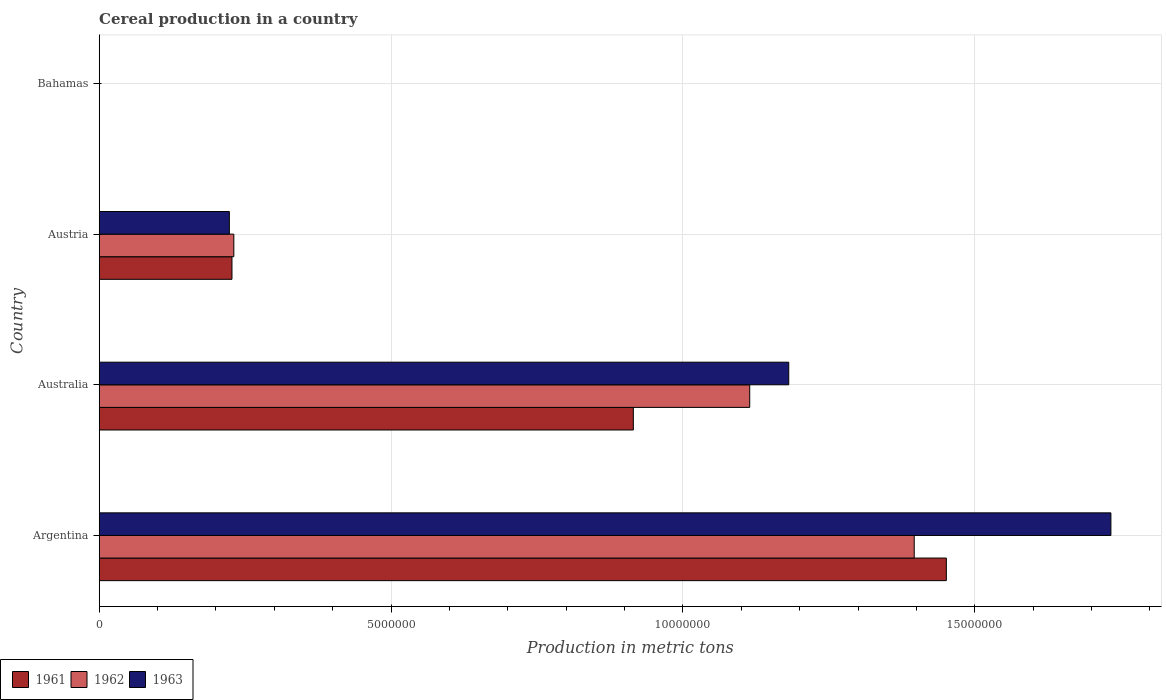How many groups of bars are there?
Offer a very short reply. 4. How many bars are there on the 3rd tick from the top?
Offer a terse response. 3. How many bars are there on the 2nd tick from the bottom?
Ensure brevity in your answer.  3. In how many cases, is the number of bars for a given country not equal to the number of legend labels?
Your response must be concise. 0. What is the total cereal production in 1962 in Bahamas?
Ensure brevity in your answer.  150. Across all countries, what is the maximum total cereal production in 1961?
Provide a short and direct response. 1.45e+07. In which country was the total cereal production in 1963 maximum?
Provide a short and direct response. Argentina. In which country was the total cereal production in 1961 minimum?
Provide a short and direct response. Bahamas. What is the total total cereal production in 1962 in the graph?
Your response must be concise. 2.74e+07. What is the difference between the total cereal production in 1963 in Argentina and that in Bahamas?
Provide a short and direct response. 1.73e+07. What is the difference between the total cereal production in 1962 in Bahamas and the total cereal production in 1961 in Australia?
Provide a succinct answer. -9.15e+06. What is the average total cereal production in 1963 per country?
Offer a very short reply. 7.84e+06. What is the difference between the total cereal production in 1963 and total cereal production in 1961 in Bahamas?
Provide a succinct answer. 100. In how many countries, is the total cereal production in 1962 greater than 7000000 metric tons?
Provide a short and direct response. 2. What is the ratio of the total cereal production in 1961 in Argentina to that in Australia?
Offer a very short reply. 1.59. What is the difference between the highest and the second highest total cereal production in 1962?
Provide a succinct answer. 2.82e+06. What is the difference between the highest and the lowest total cereal production in 1961?
Provide a short and direct response. 1.45e+07. In how many countries, is the total cereal production in 1961 greater than the average total cereal production in 1961 taken over all countries?
Your answer should be compact. 2. Is it the case that in every country, the sum of the total cereal production in 1963 and total cereal production in 1961 is greater than the total cereal production in 1962?
Keep it short and to the point. Yes. How many countries are there in the graph?
Your answer should be compact. 4. Are the values on the major ticks of X-axis written in scientific E-notation?
Give a very brief answer. No. Does the graph contain any zero values?
Provide a short and direct response. No. How many legend labels are there?
Your answer should be compact. 3. What is the title of the graph?
Offer a very short reply. Cereal production in a country. Does "1994" appear as one of the legend labels in the graph?
Ensure brevity in your answer.  No. What is the label or title of the X-axis?
Make the answer very short. Production in metric tons. What is the label or title of the Y-axis?
Your answer should be compact. Country. What is the Production in metric tons in 1961 in Argentina?
Your answer should be very brief. 1.45e+07. What is the Production in metric tons in 1962 in Argentina?
Your answer should be compact. 1.40e+07. What is the Production in metric tons of 1963 in Argentina?
Give a very brief answer. 1.73e+07. What is the Production in metric tons in 1961 in Australia?
Provide a succinct answer. 9.15e+06. What is the Production in metric tons of 1962 in Australia?
Your answer should be compact. 1.11e+07. What is the Production in metric tons of 1963 in Australia?
Offer a very short reply. 1.18e+07. What is the Production in metric tons of 1961 in Austria?
Make the answer very short. 2.27e+06. What is the Production in metric tons of 1962 in Austria?
Your response must be concise. 2.31e+06. What is the Production in metric tons of 1963 in Austria?
Offer a very short reply. 2.23e+06. What is the Production in metric tons of 1962 in Bahamas?
Provide a short and direct response. 150. What is the Production in metric tons of 1963 in Bahamas?
Your answer should be very brief. 200. Across all countries, what is the maximum Production in metric tons of 1961?
Provide a succinct answer. 1.45e+07. Across all countries, what is the maximum Production in metric tons in 1962?
Provide a short and direct response. 1.40e+07. Across all countries, what is the maximum Production in metric tons in 1963?
Give a very brief answer. 1.73e+07. Across all countries, what is the minimum Production in metric tons of 1961?
Give a very brief answer. 100. Across all countries, what is the minimum Production in metric tons of 1962?
Make the answer very short. 150. What is the total Production in metric tons of 1961 in the graph?
Your answer should be compact. 2.59e+07. What is the total Production in metric tons of 1962 in the graph?
Give a very brief answer. 2.74e+07. What is the total Production in metric tons of 1963 in the graph?
Ensure brevity in your answer.  3.14e+07. What is the difference between the Production in metric tons in 1961 in Argentina and that in Australia?
Ensure brevity in your answer.  5.36e+06. What is the difference between the Production in metric tons in 1962 in Argentina and that in Australia?
Your response must be concise. 2.82e+06. What is the difference between the Production in metric tons of 1963 in Argentina and that in Australia?
Your answer should be very brief. 5.52e+06. What is the difference between the Production in metric tons in 1961 in Argentina and that in Austria?
Your response must be concise. 1.22e+07. What is the difference between the Production in metric tons of 1962 in Argentina and that in Austria?
Ensure brevity in your answer.  1.17e+07. What is the difference between the Production in metric tons of 1963 in Argentina and that in Austria?
Your answer should be very brief. 1.51e+07. What is the difference between the Production in metric tons in 1961 in Argentina and that in Bahamas?
Your answer should be very brief. 1.45e+07. What is the difference between the Production in metric tons in 1962 in Argentina and that in Bahamas?
Your answer should be compact. 1.40e+07. What is the difference between the Production in metric tons of 1963 in Argentina and that in Bahamas?
Offer a terse response. 1.73e+07. What is the difference between the Production in metric tons in 1961 in Australia and that in Austria?
Your response must be concise. 6.88e+06. What is the difference between the Production in metric tons in 1962 in Australia and that in Austria?
Give a very brief answer. 8.84e+06. What is the difference between the Production in metric tons of 1963 in Australia and that in Austria?
Your answer should be compact. 9.58e+06. What is the difference between the Production in metric tons in 1961 in Australia and that in Bahamas?
Offer a terse response. 9.15e+06. What is the difference between the Production in metric tons of 1962 in Australia and that in Bahamas?
Offer a very short reply. 1.11e+07. What is the difference between the Production in metric tons of 1963 in Australia and that in Bahamas?
Provide a short and direct response. 1.18e+07. What is the difference between the Production in metric tons in 1961 in Austria and that in Bahamas?
Your answer should be very brief. 2.27e+06. What is the difference between the Production in metric tons in 1962 in Austria and that in Bahamas?
Ensure brevity in your answer.  2.31e+06. What is the difference between the Production in metric tons of 1963 in Austria and that in Bahamas?
Your answer should be compact. 2.23e+06. What is the difference between the Production in metric tons in 1961 in Argentina and the Production in metric tons in 1962 in Australia?
Your answer should be compact. 3.37e+06. What is the difference between the Production in metric tons of 1961 in Argentina and the Production in metric tons of 1963 in Australia?
Provide a short and direct response. 2.70e+06. What is the difference between the Production in metric tons of 1962 in Argentina and the Production in metric tons of 1963 in Australia?
Offer a terse response. 2.15e+06. What is the difference between the Production in metric tons of 1961 in Argentina and the Production in metric tons of 1962 in Austria?
Make the answer very short. 1.22e+07. What is the difference between the Production in metric tons in 1961 in Argentina and the Production in metric tons in 1963 in Austria?
Give a very brief answer. 1.23e+07. What is the difference between the Production in metric tons in 1962 in Argentina and the Production in metric tons in 1963 in Austria?
Give a very brief answer. 1.17e+07. What is the difference between the Production in metric tons of 1961 in Argentina and the Production in metric tons of 1962 in Bahamas?
Your response must be concise. 1.45e+07. What is the difference between the Production in metric tons in 1961 in Argentina and the Production in metric tons in 1963 in Bahamas?
Provide a succinct answer. 1.45e+07. What is the difference between the Production in metric tons in 1962 in Argentina and the Production in metric tons in 1963 in Bahamas?
Keep it short and to the point. 1.40e+07. What is the difference between the Production in metric tons of 1961 in Australia and the Production in metric tons of 1962 in Austria?
Keep it short and to the point. 6.84e+06. What is the difference between the Production in metric tons in 1961 in Australia and the Production in metric tons in 1963 in Austria?
Your answer should be compact. 6.92e+06. What is the difference between the Production in metric tons in 1962 in Australia and the Production in metric tons in 1963 in Austria?
Provide a short and direct response. 8.91e+06. What is the difference between the Production in metric tons of 1961 in Australia and the Production in metric tons of 1962 in Bahamas?
Your answer should be very brief. 9.15e+06. What is the difference between the Production in metric tons in 1961 in Australia and the Production in metric tons in 1963 in Bahamas?
Make the answer very short. 9.15e+06. What is the difference between the Production in metric tons in 1962 in Australia and the Production in metric tons in 1963 in Bahamas?
Make the answer very short. 1.11e+07. What is the difference between the Production in metric tons of 1961 in Austria and the Production in metric tons of 1962 in Bahamas?
Your answer should be very brief. 2.27e+06. What is the difference between the Production in metric tons in 1961 in Austria and the Production in metric tons in 1963 in Bahamas?
Provide a short and direct response. 2.27e+06. What is the difference between the Production in metric tons of 1962 in Austria and the Production in metric tons of 1963 in Bahamas?
Keep it short and to the point. 2.31e+06. What is the average Production in metric tons of 1961 per country?
Ensure brevity in your answer.  6.48e+06. What is the average Production in metric tons of 1962 per country?
Provide a short and direct response. 6.85e+06. What is the average Production in metric tons of 1963 per country?
Give a very brief answer. 7.84e+06. What is the difference between the Production in metric tons in 1961 and Production in metric tons in 1962 in Argentina?
Offer a terse response. 5.50e+05. What is the difference between the Production in metric tons of 1961 and Production in metric tons of 1963 in Argentina?
Offer a very short reply. -2.82e+06. What is the difference between the Production in metric tons in 1962 and Production in metric tons in 1963 in Argentina?
Keep it short and to the point. -3.37e+06. What is the difference between the Production in metric tons of 1961 and Production in metric tons of 1962 in Australia?
Your answer should be very brief. -1.99e+06. What is the difference between the Production in metric tons of 1961 and Production in metric tons of 1963 in Australia?
Offer a terse response. -2.66e+06. What is the difference between the Production in metric tons of 1962 and Production in metric tons of 1963 in Australia?
Ensure brevity in your answer.  -6.69e+05. What is the difference between the Production in metric tons of 1961 and Production in metric tons of 1962 in Austria?
Offer a terse response. -3.19e+04. What is the difference between the Production in metric tons of 1961 and Production in metric tons of 1963 in Austria?
Ensure brevity in your answer.  4.45e+04. What is the difference between the Production in metric tons in 1962 and Production in metric tons in 1963 in Austria?
Offer a very short reply. 7.65e+04. What is the difference between the Production in metric tons in 1961 and Production in metric tons in 1963 in Bahamas?
Your answer should be very brief. -100. What is the ratio of the Production in metric tons of 1961 in Argentina to that in Australia?
Keep it short and to the point. 1.59. What is the ratio of the Production in metric tons of 1962 in Argentina to that in Australia?
Offer a terse response. 1.25. What is the ratio of the Production in metric tons of 1963 in Argentina to that in Australia?
Provide a short and direct response. 1.47. What is the ratio of the Production in metric tons of 1961 in Argentina to that in Austria?
Your answer should be very brief. 6.38. What is the ratio of the Production in metric tons in 1962 in Argentina to that in Austria?
Provide a succinct answer. 6.05. What is the ratio of the Production in metric tons of 1963 in Argentina to that in Austria?
Ensure brevity in your answer.  7.77. What is the ratio of the Production in metric tons in 1961 in Argentina to that in Bahamas?
Ensure brevity in your answer.  1.45e+05. What is the ratio of the Production in metric tons in 1962 in Argentina to that in Bahamas?
Provide a succinct answer. 9.31e+04. What is the ratio of the Production in metric tons in 1963 in Argentina to that in Bahamas?
Your answer should be compact. 8.67e+04. What is the ratio of the Production in metric tons in 1961 in Australia to that in Austria?
Offer a terse response. 4.02. What is the ratio of the Production in metric tons of 1962 in Australia to that in Austria?
Give a very brief answer. 4.83. What is the ratio of the Production in metric tons of 1963 in Australia to that in Austria?
Your answer should be compact. 5.3. What is the ratio of the Production in metric tons of 1961 in Australia to that in Bahamas?
Keep it short and to the point. 9.15e+04. What is the ratio of the Production in metric tons in 1962 in Australia to that in Bahamas?
Your response must be concise. 7.43e+04. What is the ratio of the Production in metric tons in 1963 in Australia to that in Bahamas?
Give a very brief answer. 5.91e+04. What is the ratio of the Production in metric tons of 1961 in Austria to that in Bahamas?
Offer a terse response. 2.27e+04. What is the ratio of the Production in metric tons in 1962 in Austria to that in Bahamas?
Offer a terse response. 1.54e+04. What is the ratio of the Production in metric tons in 1963 in Austria to that in Bahamas?
Offer a terse response. 1.11e+04. What is the difference between the highest and the second highest Production in metric tons of 1961?
Your answer should be compact. 5.36e+06. What is the difference between the highest and the second highest Production in metric tons in 1962?
Offer a terse response. 2.82e+06. What is the difference between the highest and the second highest Production in metric tons in 1963?
Provide a short and direct response. 5.52e+06. What is the difference between the highest and the lowest Production in metric tons in 1961?
Your answer should be very brief. 1.45e+07. What is the difference between the highest and the lowest Production in metric tons in 1962?
Your answer should be very brief. 1.40e+07. What is the difference between the highest and the lowest Production in metric tons in 1963?
Your answer should be very brief. 1.73e+07. 